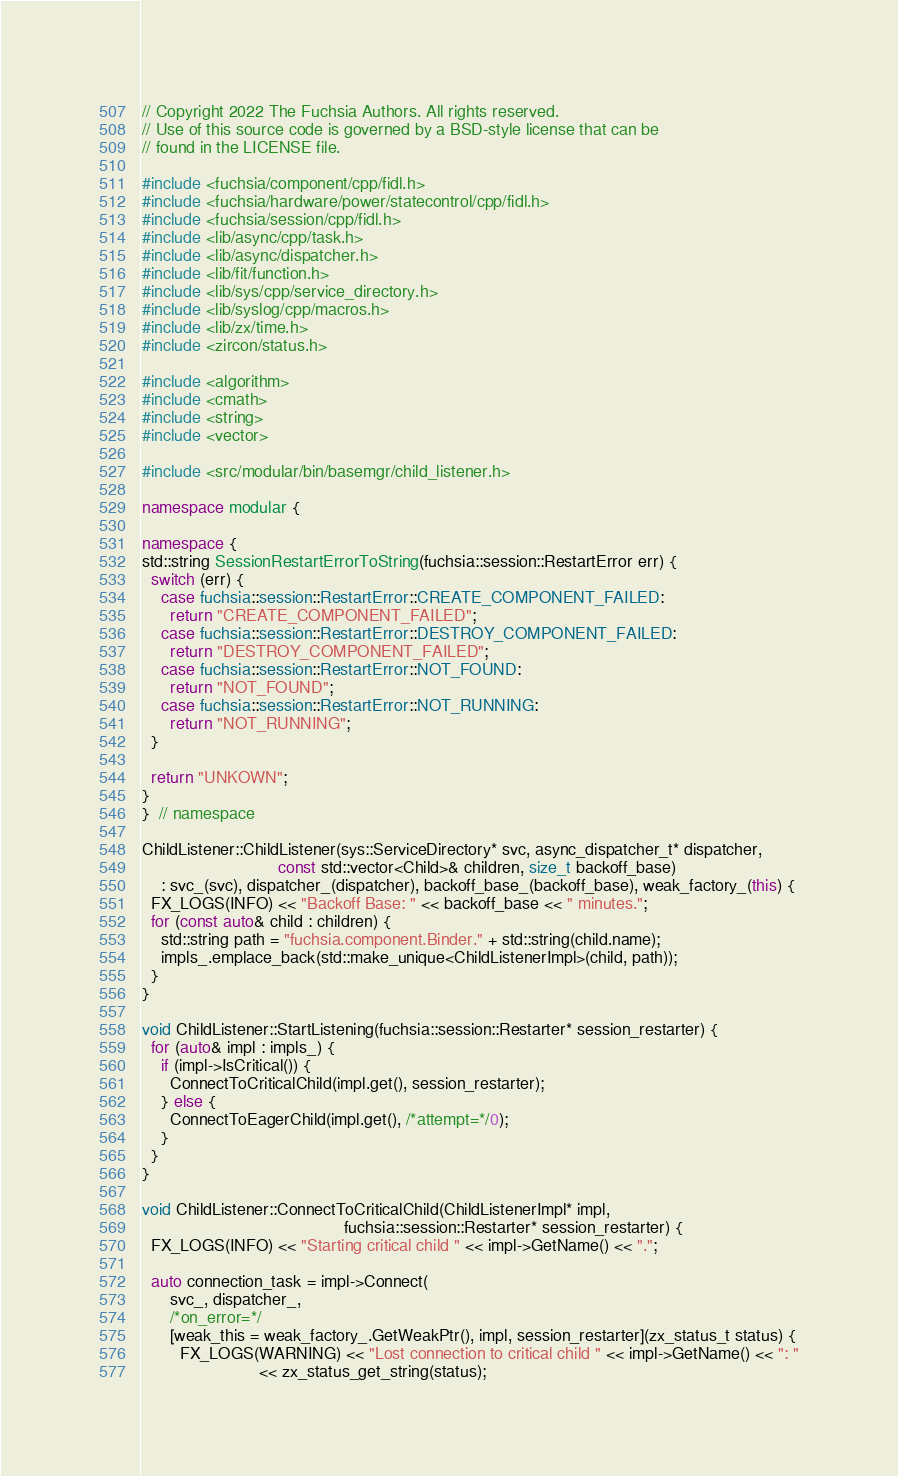Convert code to text. <code><loc_0><loc_0><loc_500><loc_500><_C++_>// Copyright 2022 The Fuchsia Authors. All rights reserved.
// Use of this source code is governed by a BSD-style license that can be
// found in the LICENSE file.

#include <fuchsia/component/cpp/fidl.h>
#include <fuchsia/hardware/power/statecontrol/cpp/fidl.h>
#include <fuchsia/session/cpp/fidl.h>
#include <lib/async/cpp/task.h>
#include <lib/async/dispatcher.h>
#include <lib/fit/function.h>
#include <lib/sys/cpp/service_directory.h>
#include <lib/syslog/cpp/macros.h>
#include <lib/zx/time.h>
#include <zircon/status.h>

#include <algorithm>
#include <cmath>
#include <string>
#include <vector>

#include <src/modular/bin/basemgr/child_listener.h>

namespace modular {

namespace {
std::string SessionRestartErrorToString(fuchsia::session::RestartError err) {
  switch (err) {
    case fuchsia::session::RestartError::CREATE_COMPONENT_FAILED:
      return "CREATE_COMPONENT_FAILED";
    case fuchsia::session::RestartError::DESTROY_COMPONENT_FAILED:
      return "DESTROY_COMPONENT_FAILED";
    case fuchsia::session::RestartError::NOT_FOUND:
      return "NOT_FOUND";
    case fuchsia::session::RestartError::NOT_RUNNING:
      return "NOT_RUNNING";
  }

  return "UNKOWN";
}
}  // namespace

ChildListener::ChildListener(sys::ServiceDirectory* svc, async_dispatcher_t* dispatcher,
                             const std::vector<Child>& children, size_t backoff_base)
    : svc_(svc), dispatcher_(dispatcher), backoff_base_(backoff_base), weak_factory_(this) {
  FX_LOGS(INFO) << "Backoff Base: " << backoff_base << " minutes.";
  for (const auto& child : children) {
    std::string path = "fuchsia.component.Binder." + std::string(child.name);
    impls_.emplace_back(std::make_unique<ChildListenerImpl>(child, path));
  }
}

void ChildListener::StartListening(fuchsia::session::Restarter* session_restarter) {
  for (auto& impl : impls_) {
    if (impl->IsCritical()) {
      ConnectToCriticalChild(impl.get(), session_restarter);
    } else {
      ConnectToEagerChild(impl.get(), /*attempt=*/0);
    }
  }
}

void ChildListener::ConnectToCriticalChild(ChildListenerImpl* impl,
                                           fuchsia::session::Restarter* session_restarter) {
  FX_LOGS(INFO) << "Starting critical child " << impl->GetName() << ".";

  auto connection_task = impl->Connect(
      svc_, dispatcher_,
      /*on_error=*/
      [weak_this = weak_factory_.GetWeakPtr(), impl, session_restarter](zx_status_t status) {
        FX_LOGS(WARNING) << "Lost connection to critical child " << impl->GetName() << ": "
                         << zx_status_get_string(status);</code> 